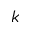<formula> <loc_0><loc_0><loc_500><loc_500>k</formula> 